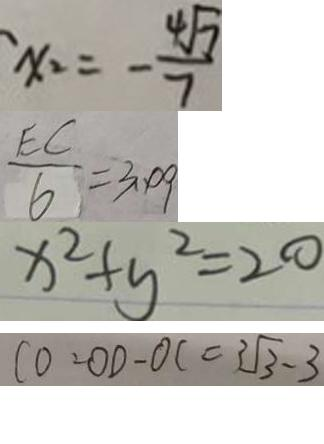<formula> <loc_0><loc_0><loc_500><loc_500>x _ { 2 } = - \frac { 4 \sqrt { 7 } } { 7 } 
 \frac { E C } { 6 } = 3 . 0 9 
 x ^ { 2 } + y ^ { 2 } = 2 0 
 C 0 = O D - O C = 3 \sqrt { 3 } - 3</formula> 